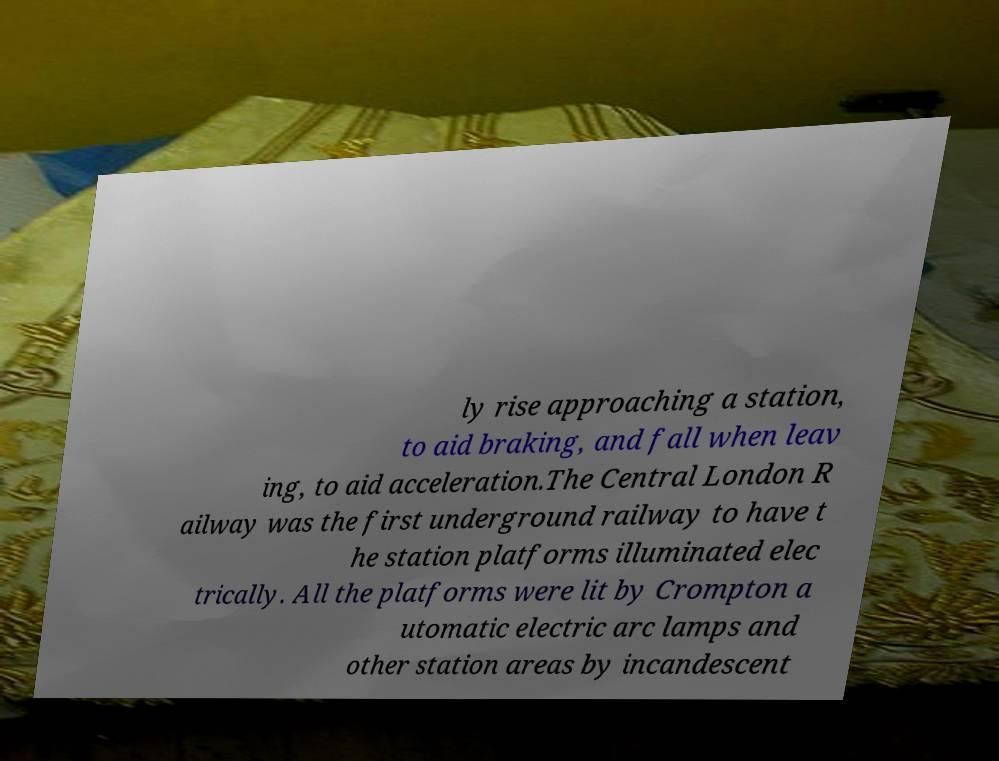For documentation purposes, I need the text within this image transcribed. Could you provide that? ly rise approaching a station, to aid braking, and fall when leav ing, to aid acceleration.The Central London R ailway was the first underground railway to have t he station platforms illuminated elec trically. All the platforms were lit by Crompton a utomatic electric arc lamps and other station areas by incandescent 